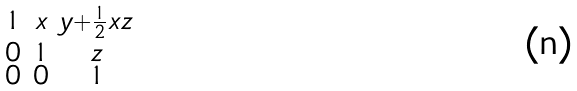Convert formula to latex. <formula><loc_0><loc_0><loc_500><loc_500>\begin{smallmatrix} 1 & x & y + \frac { 1 } { 2 } x z \\ 0 & 1 & z \\ 0 & 0 & 1 \end{smallmatrix}</formula> 